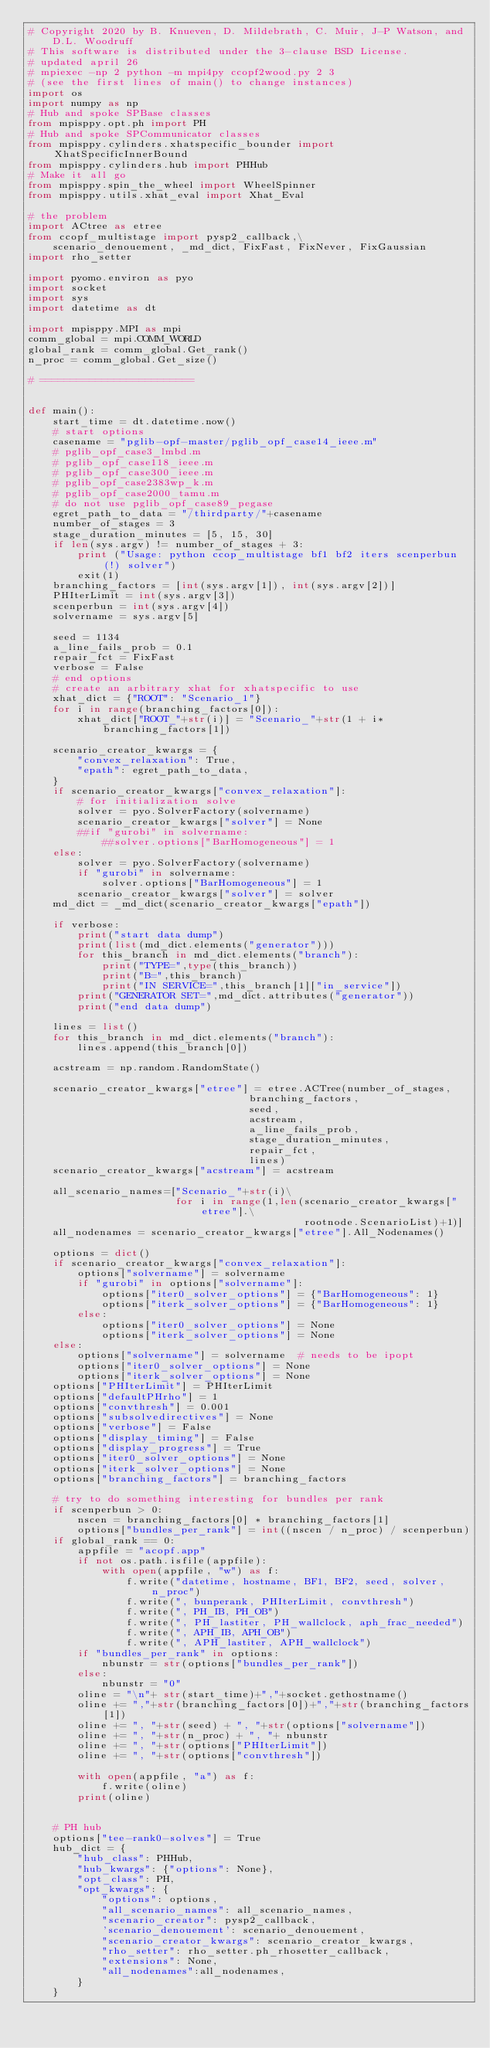<code> <loc_0><loc_0><loc_500><loc_500><_Python_># Copyright 2020 by B. Knueven, D. Mildebrath, C. Muir, J-P Watson, and D.L. Woodruff
# This software is distributed under the 3-clause BSD License.
# updated april 26
# mpiexec -np 2 python -m mpi4py ccopf2wood.py 2 3
# (see the first lines of main() to change instances)
import os
import numpy as np
# Hub and spoke SPBase classes
from mpisppy.opt.ph import PH
# Hub and spoke SPCommunicator classes
from mpisppy.cylinders.xhatspecific_bounder import XhatSpecificInnerBound
from mpisppy.cylinders.hub import PHHub
# Make it all go
from mpisppy.spin_the_wheel import WheelSpinner
from mpisppy.utils.xhat_eval import Xhat_Eval

# the problem
import ACtree as etree
from ccopf_multistage import pysp2_callback,\
    scenario_denouement, _md_dict, FixFast, FixNever, FixGaussian
import rho_setter

import pyomo.environ as pyo
import socket
import sys
import datetime as dt

import mpisppy.MPI as mpi
comm_global = mpi.COMM_WORLD
global_rank = comm_global.Get_rank()
n_proc = comm_global.Get_size()

# =========================


def main():
    start_time = dt.datetime.now()
    # start options
    casename = "pglib-opf-master/pglib_opf_case14_ieee.m"
    # pglib_opf_case3_lmbd.m
    # pglib_opf_case118_ieee.m
    # pglib_opf_case300_ieee.m
    # pglib_opf_case2383wp_k.m
    # pglib_opf_case2000_tamu.m
    # do not use pglib_opf_case89_pegase
    egret_path_to_data = "/thirdparty/"+casename
    number_of_stages = 3
    stage_duration_minutes = [5, 15, 30]
    if len(sys.argv) != number_of_stages + 3:
        print ("Usage: python ccop_multistage bf1 bf2 iters scenperbun(!) solver")
        exit(1)
    branching_factors = [int(sys.argv[1]), int(sys.argv[2])]
    PHIterLimit = int(sys.argv[3])
    scenperbun = int(sys.argv[4])
    solvername = sys.argv[5]

    seed = 1134
    a_line_fails_prob = 0.1
    repair_fct = FixFast
    verbose = False
    # end options
    # create an arbitrary xhat for xhatspecific to use
    xhat_dict = {"ROOT": "Scenario_1"}
    for i in range(branching_factors[0]):
        xhat_dict["ROOT_"+str(i)] = "Scenario_"+str(1 + i*branching_factors[1])

    scenario_creator_kwargs = {
        "convex_relaxation": True,
        "epath": egret_path_to_data,
    }
    if scenario_creator_kwargs["convex_relaxation"]:
        # for initialization solve
        solver = pyo.SolverFactory(solvername)
        scenario_creator_kwargs["solver"] = None
        ##if "gurobi" in solvername:
            ##solver.options["BarHomogeneous"] = 1
    else:
        solver = pyo.SolverFactory(solvername)
        if "gurobi" in solvername:
            solver.options["BarHomogeneous"] = 1
        scenario_creator_kwargs["solver"] = solver
    md_dict = _md_dict(scenario_creator_kwargs["epath"])

    if verbose:
        print("start data dump")
        print(list(md_dict.elements("generator")))
        for this_branch in md_dict.elements("branch"): 
            print("TYPE=",type(this_branch))
            print("B=",this_branch)
            print("IN SERVICE=",this_branch[1]["in_service"])
        print("GENERATOR SET=",md_dict.attributes("generator"))
        print("end data dump")

    lines = list()
    for this_branch in md_dict.elements("branch"):
        lines.append(this_branch[0])

    acstream = np.random.RandomState()
        
    scenario_creator_kwargs["etree"] = etree.ACTree(number_of_stages,
                                    branching_factors,
                                    seed,
                                    acstream,
                                    a_line_fails_prob,
                                    stage_duration_minutes,
                                    repair_fct,
                                    lines)
    scenario_creator_kwargs["acstream"] = acstream

    all_scenario_names=["Scenario_"+str(i)\
                        for i in range(1,len(scenario_creator_kwargs["etree"].\
                                             rootnode.ScenarioList)+1)]
    all_nodenames = scenario_creator_kwargs["etree"].All_Nodenames()

    options = dict()
    if scenario_creator_kwargs["convex_relaxation"]:
        options["solvername"] = solvername
        if "gurobi" in options["solvername"]:
            options["iter0_solver_options"] = {"BarHomogeneous": 1}
            options["iterk_solver_options"] = {"BarHomogeneous": 1}
        else:
            options["iter0_solver_options"] = None
            options["iterk_solver_options"] = None
    else:
        options["solvername"] = solvername  # needs to be ipopt
        options["iter0_solver_options"] = None
        options["iterk_solver_options"] = None
    options["PHIterLimit"] = PHIterLimit
    options["defaultPHrho"] = 1
    options["convthresh"] = 0.001
    options["subsolvedirectives"] = None
    options["verbose"] = False
    options["display_timing"] = False
    options["display_progress"] = True
    options["iter0_solver_options"] = None
    options["iterk_solver_options"] = None
    options["branching_factors"] = branching_factors

    # try to do something interesting for bundles per rank
    if scenperbun > 0:
        nscen = branching_factors[0] * branching_factors[1]
        options["bundles_per_rank"] = int((nscen / n_proc) / scenperbun)
    if global_rank == 0:
        appfile = "acopf.app"
        if not os.path.isfile(appfile):
            with open(appfile, "w") as f:
                f.write("datetime, hostname, BF1, BF2, seed, solver, n_proc")
                f.write(", bunperank, PHIterLimit, convthresh")
                f.write(", PH_IB, PH_OB")
                f.write(", PH_lastiter, PH_wallclock, aph_frac_needed")
                f.write(", APH_IB, APH_OB")
                f.write(", APH_lastiter, APH_wallclock")
        if "bundles_per_rank" in options:
            nbunstr = str(options["bundles_per_rank"])
        else:
            nbunstr = "0"
        oline = "\n"+ str(start_time)+","+socket.gethostname()
        oline += ","+str(branching_factors[0])+","+str(branching_factors[1])
        oline += ", "+str(seed) + ", "+str(options["solvername"])
        oline += ", "+str(n_proc) + ", "+ nbunstr
        oline += ", "+str(options["PHIterLimit"])
        oline += ", "+str(options["convthresh"])

        with open(appfile, "a") as f:
            f.write(oline)
        print(oline)


    # PH hub
    options["tee-rank0-solves"] = True
    hub_dict = {
        "hub_class": PHHub,
        "hub_kwargs": {"options": None},
        "opt_class": PH,
        "opt_kwargs": {
            "options": options,
            "all_scenario_names": all_scenario_names,
            "scenario_creator": pysp2_callback,
            'scenario_denouement': scenario_denouement,
            "scenario_creator_kwargs": scenario_creator_kwargs,
            "rho_setter": rho_setter.ph_rhosetter_callback,
            "extensions": None,
            "all_nodenames":all_nodenames,
        }
    }
</code> 